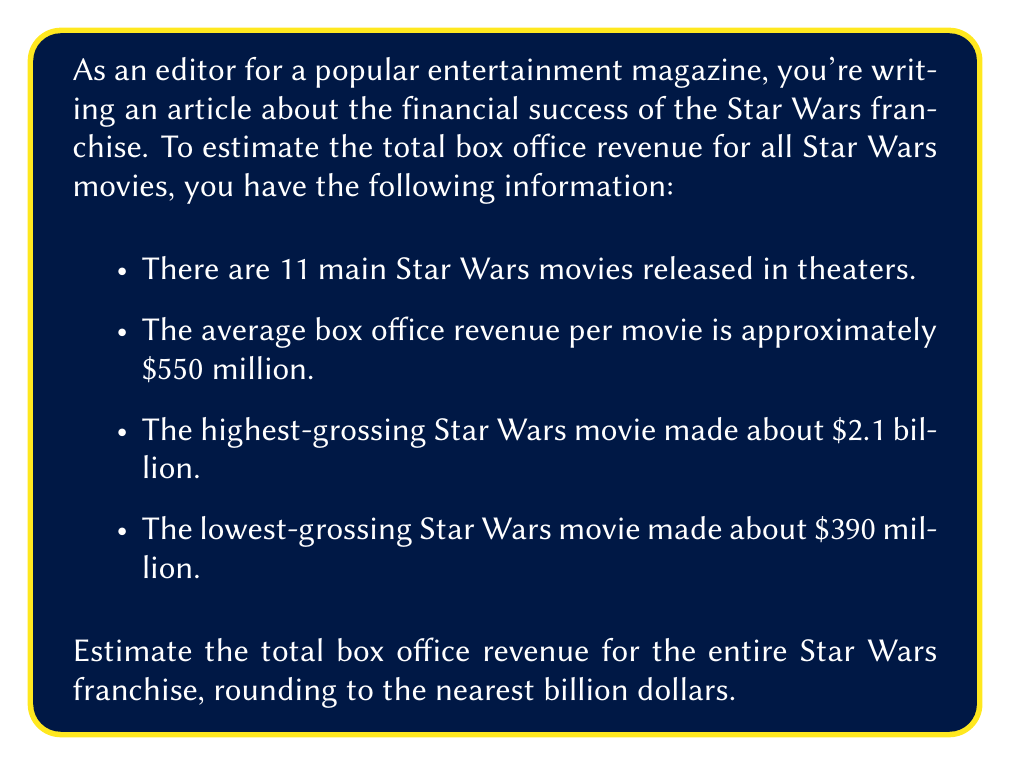Could you help me with this problem? To estimate the total box office revenue for the entire Star Wars franchise, we'll use the average box office revenue per movie and multiply it by the number of movies. This method provides a reasonable estimate without needing to know the exact revenue for each film.

Given:
- Number of main Star Wars movies: 11
- Average box office revenue per movie: $550 million

Step 1: Calculate the estimated total revenue
$$\text{Total Revenue} = \text{Number of Movies} \times \text{Average Revenue per Movie}$$
$$\text{Total Revenue} = 11 \times \$550 \text{ million}$$
$$\text{Total Revenue} = \$6,050 \text{ million}$$

Step 2: Convert to billions and round to the nearest billion
$$\$6,050 \text{ million} = \$6.05 \text{ billion}$$

Rounding to the nearest billion: $\$6 \text{ billion}$

This estimate aligns with the given information:
- It's higher than 11 times the lowest-grossing movie: $11 \times \$390 \text{ million} = \$4.29 \text{ billion}$
- It's lower than 11 times the highest-grossing movie: $11 \times \$2.1 \text{ billion} = \$23.1 \text{ billion}$

Therefore, our estimate of $6 billion seems reasonable given the provided information.
Answer: $6 billion 